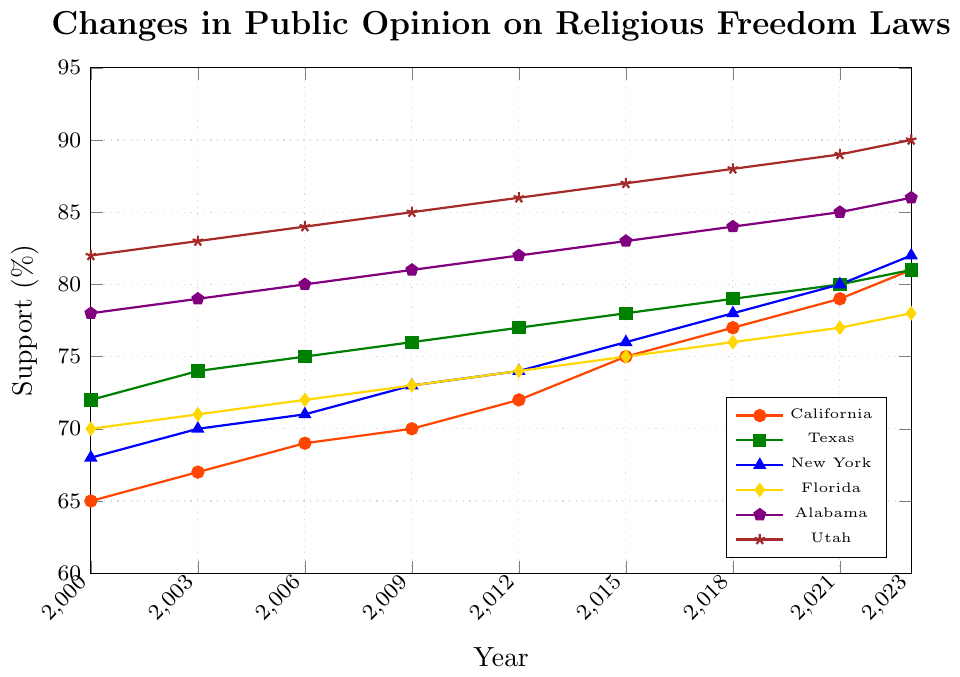What is the trend of support for religious freedom laws in California from 2000 to 2023? To analyze the trend, we observe the plot line for California which indicates a continuous increase from 65% in 2000 to 81% in 2023.
Answer: Continuous increase Which state had the lowest support percentage for religious freedom laws in 2000? By looking at the starting points of all the lines in the graph for the year 2000, California has the lowest point at 65%.
Answer: California What is the difference in support for religious freedom laws between Alabama and Utah in 2023? Subtract the 2023 value for Alabama (86%) from that of Utah (90%). The difference is 90% - 86% = 4%.
Answer: 4% From the data given, which state shows the greatest increase in support from 2000 to 2023? Calculate the difference in support between 2000 and 2023 for each state: California (81-65=16), Texas (81-72=9), New York (82-68=14), Florida (78-70=8), Alabama (86-78=8), Utah (90-82=8). The state with the greatest increase is California with an increase of 16%.
Answer: California What is the average support for religious freedom laws in Texas over the period 2000 to 2023? Sum the values for Texas from 2000 to 2023 (72 + 74 + 75 + 76 + 77 + 78 + 79 + 80 + 81 = 692) and divide by the number of data points (9 years). 692 / 9 ≈ 76.89.
Answer: 76.89 In 2023, which state had the highest support for religious freedom laws? By examining the endpoints of the lines for 2023, Utah has the highest support at 90%.
Answer: Utah Compare the support percentage for religious freedom laws between New York and Florida in 2015. By locating the values for 2015 for both states, New York has 76% while Florida has 75%. New York has a 1% higher support.
Answer: New York Which state showed a consistent linear increase over the years 2000 to 2023? Observing the lines, all states show a consistent linear increase in support from 2000 to 2023.
Answer: All states How much did the support for religious freedom laws in Florida increase between 2006 and 2018? Subtract the support in 2006 (72%) from that in 2018 (76%). The increase is 76% - 72% = 4%.
Answer: 4% Did any state show a decrease in support for religious freedom laws at any point between 2000 and 2023? Analyzing all the plotted lines, none of the states show a decrease in support; all lines consistently increase upward.
Answer: No 